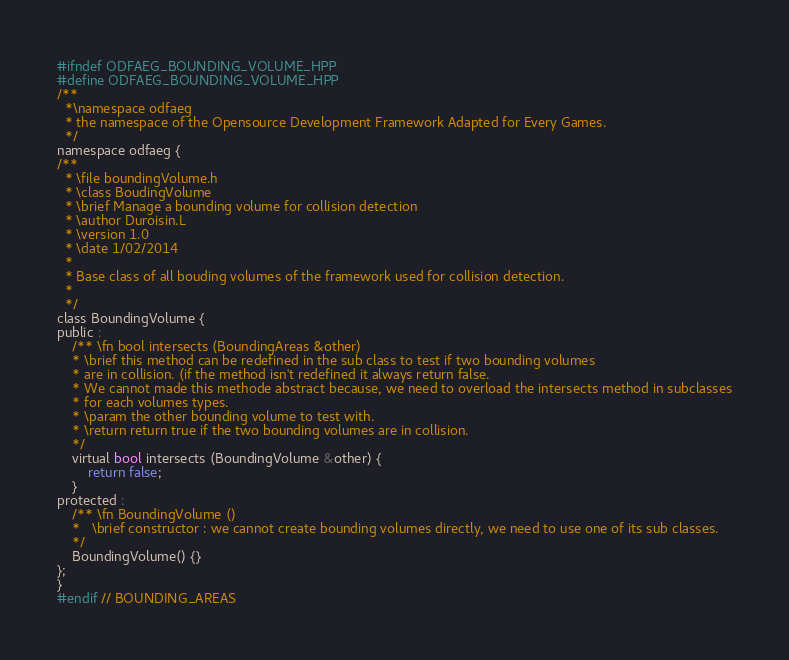Convert code to text. <code><loc_0><loc_0><loc_500><loc_500><_C_>#ifndef ODFAEG_BOUNDING_VOLUME_HPP
#define ODFAEG_BOUNDING_VOLUME_HPP
/**
  *\namespace odfaeg
  * the namespace of the Opensource Development Framework Adapted for Every Games.
  */
namespace odfaeg {
/**
  * \file boundingVolume.h
  * \class BoudingVolume
  * \brief Manage a bounding volume for collision detection
  * \author Duroisin.L
  * \version 1.0
  * \date 1/02/2014
  *
  * Base class of all bouding volumes of the framework used for collision detection.
  *
  */
class BoundingVolume {
public :
    /** \fn bool intersects (BoundingAreas &other)
    * \brief this method can be redefined in the sub class to test if two bounding volumes
    * are in collision. (if the method isn't redefined it always return false.
    * We cannot made this methode abstract because, we need to overload the intersects method in subclasses
    * for each volumes types.
    * \param the other bounding volume to test with.
    * \return return true if the two bounding volumes are in collision.
    */
    virtual bool intersects (BoundingVolume &other) {
        return false;
    }
protected :
    /** \fn BoundingVolume ()
    *   \brief constructor : we cannot create bounding volumes directly, we need to use one of its sub classes.
    */
    BoundingVolume() {}
};
}
#endif // BOUNDING_AREAS
</code> 